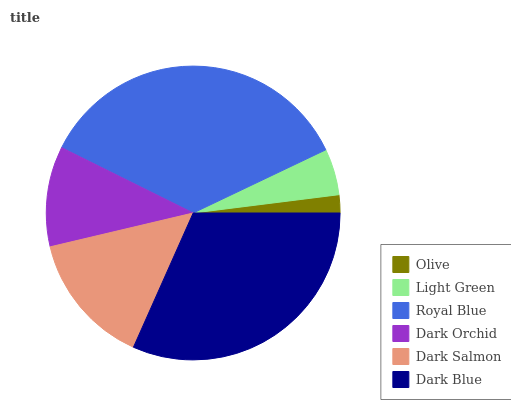Is Olive the minimum?
Answer yes or no. Yes. Is Royal Blue the maximum?
Answer yes or no. Yes. Is Light Green the minimum?
Answer yes or no. No. Is Light Green the maximum?
Answer yes or no. No. Is Light Green greater than Olive?
Answer yes or no. Yes. Is Olive less than Light Green?
Answer yes or no. Yes. Is Olive greater than Light Green?
Answer yes or no. No. Is Light Green less than Olive?
Answer yes or no. No. Is Dark Salmon the high median?
Answer yes or no. Yes. Is Dark Orchid the low median?
Answer yes or no. Yes. Is Olive the high median?
Answer yes or no. No. Is Light Green the low median?
Answer yes or no. No. 